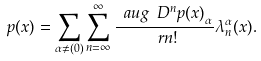Convert formula to latex. <formula><loc_0><loc_0><loc_500><loc_500>p ( x ) = \sum _ { \alpha \neq ( 0 ) } \sum _ { n = \infty } ^ { \infty } \frac { \ a u g { \ D ^ { n } p ( x ) } _ { \alpha } } { \ r { n } ! } \lambda _ { n } ^ { \alpha } ( x ) .</formula> 